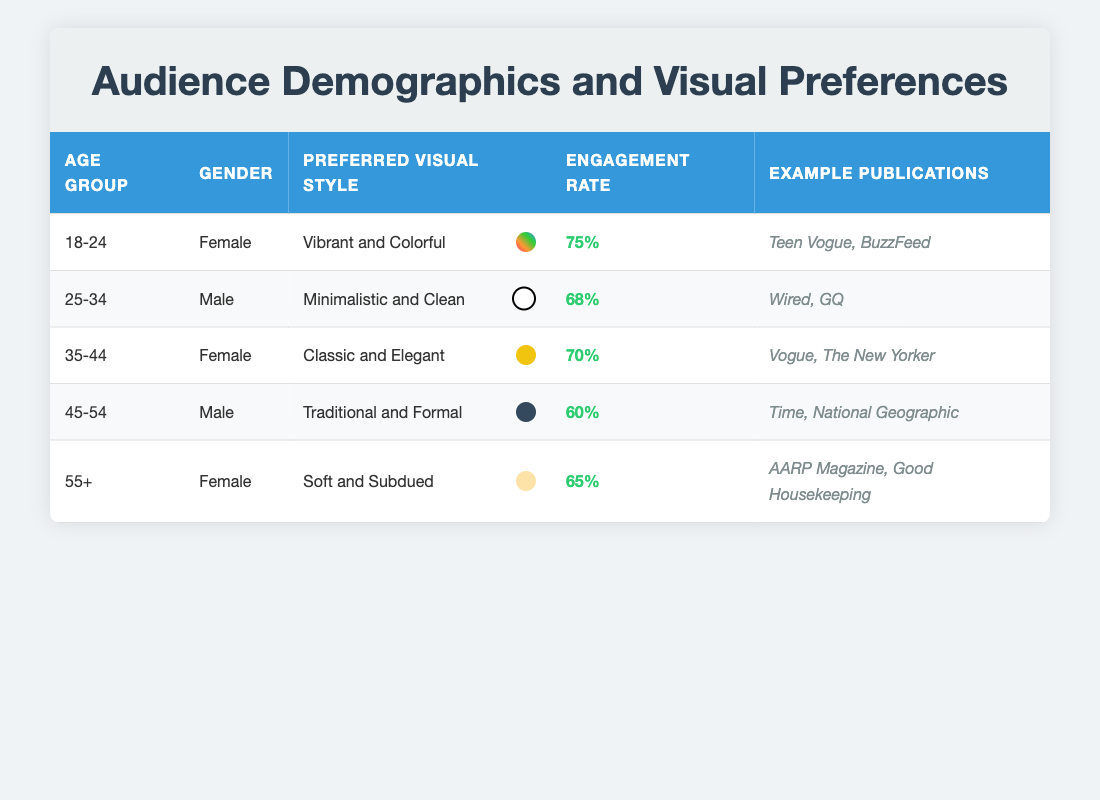What is the preferred visual style of the 35-44 age group? The table shows that the preferred visual style for the 35-44 age group is "Classic and Elegant."
Answer: Classic and Elegant Which age group has the highest engagement rate? The engagement rates are 75, 68, 70, 60, and 65 for the age groups listed. The highest engagement rate is 75 for the 18-24 age group.
Answer: 18-24 Is there a male audience that prefers a vibrant and colorful visual style? The table reveals that a vibrant and colorful visual style is preferred by females in the 18-24 age group. No males are indicated to prefer this style.
Answer: No What is the average engagement rate of the female audience? The engagement rates for females are 75 (18-24), 70 (35-44), and 65 (55+). Summing these gives 75 + 70 + 65 = 210. There are 3 data points, so the average engagement rate for females is 210 / 3 = 70.
Answer: 70 Do readers aged 45-54 prefer a minimalistic and clean visual style? According to the table, readers aged 45-54 prefer a "Traditional and Formal" visual style, not minimalistic and clean.
Answer: No What is the preferred visual style of male readers aged 25-34? The table shows that male readers aged 25-34 prefer a "Minimalistic and Clean" visual style.
Answer: Minimalistic and Clean Which gender prefers "Soft and Subdued" visuals, and what is their engagement rate? The table states that the "Soft and Subdued" visual style is preferred by females aged 55+, with an engagement rate of 65.
Answer: Female, 65 How many example publications are mentioned for the 45-54 age group? The table lists two example publications for the 45-54 age group: "Time" and "National Geographic." Hence, the total is 2.
Answer: 2 What engagement rate difference exists between the 25-34 and 45-54 age groups? The engagement rate for the 25-34 age group is 68 and for the 45-54 age group is 60. The difference is 68 - 60 = 8.
Answer: 8 